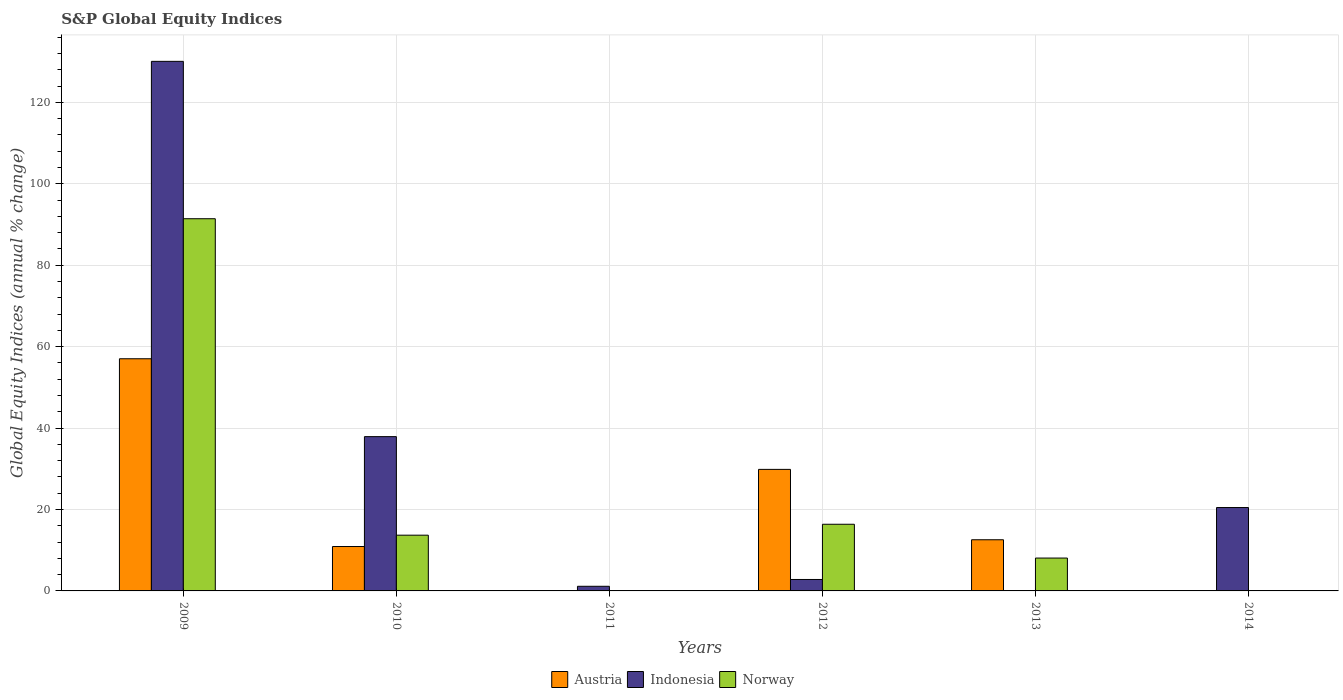Are the number of bars per tick equal to the number of legend labels?
Offer a terse response. No. Are the number of bars on each tick of the X-axis equal?
Keep it short and to the point. No. How many bars are there on the 5th tick from the left?
Provide a short and direct response. 2. In how many cases, is the number of bars for a given year not equal to the number of legend labels?
Ensure brevity in your answer.  3. What is the global equity indices in Norway in 2009?
Offer a terse response. 91.41. Across all years, what is the maximum global equity indices in Norway?
Give a very brief answer. 91.41. In which year was the global equity indices in Austria maximum?
Provide a succinct answer. 2009. What is the total global equity indices in Indonesia in the graph?
Your answer should be very brief. 192.39. What is the difference between the global equity indices in Indonesia in 2011 and that in 2014?
Offer a very short reply. -19.34. What is the difference between the global equity indices in Norway in 2009 and the global equity indices in Indonesia in 2013?
Keep it short and to the point. 91.41. What is the average global equity indices in Austria per year?
Make the answer very short. 18.39. In the year 2009, what is the difference between the global equity indices in Austria and global equity indices in Norway?
Give a very brief answer. -34.39. What is the ratio of the global equity indices in Indonesia in 2011 to that in 2014?
Provide a short and direct response. 0.06. What is the difference between the highest and the second highest global equity indices in Austria?
Keep it short and to the point. 27.17. What is the difference between the highest and the lowest global equity indices in Norway?
Offer a terse response. 91.41. Is the sum of the global equity indices in Indonesia in 2010 and 2014 greater than the maximum global equity indices in Austria across all years?
Make the answer very short. Yes. Is it the case that in every year, the sum of the global equity indices in Norway and global equity indices in Indonesia is greater than the global equity indices in Austria?
Your answer should be compact. No. How many years are there in the graph?
Your answer should be very brief. 6. What is the difference between two consecutive major ticks on the Y-axis?
Offer a terse response. 20. Does the graph contain grids?
Offer a terse response. Yes. How many legend labels are there?
Your response must be concise. 3. How are the legend labels stacked?
Give a very brief answer. Horizontal. What is the title of the graph?
Your answer should be compact. S&P Global Equity Indices. Does "Panama" appear as one of the legend labels in the graph?
Offer a terse response. No. What is the label or title of the Y-axis?
Offer a terse response. Global Equity Indices (annual % change). What is the Global Equity Indices (annual % change) of Austria in 2009?
Your response must be concise. 57.02. What is the Global Equity Indices (annual % change) of Indonesia in 2009?
Offer a terse response. 130.07. What is the Global Equity Indices (annual % change) in Norway in 2009?
Make the answer very short. 91.41. What is the Global Equity Indices (annual % change) of Austria in 2010?
Offer a terse response. 10.9. What is the Global Equity Indices (annual % change) of Indonesia in 2010?
Ensure brevity in your answer.  37.89. What is the Global Equity Indices (annual % change) in Norway in 2010?
Provide a succinct answer. 13.69. What is the Global Equity Indices (annual % change) of Indonesia in 2011?
Your answer should be compact. 1.14. What is the Global Equity Indices (annual % change) in Austria in 2012?
Your answer should be compact. 29.85. What is the Global Equity Indices (annual % change) in Indonesia in 2012?
Provide a short and direct response. 2.81. What is the Global Equity Indices (annual % change) of Norway in 2012?
Offer a very short reply. 16.37. What is the Global Equity Indices (annual % change) of Austria in 2013?
Offer a terse response. 12.57. What is the Global Equity Indices (annual % change) of Norway in 2013?
Offer a terse response. 8.07. What is the Global Equity Indices (annual % change) of Indonesia in 2014?
Provide a succinct answer. 20.48. What is the Global Equity Indices (annual % change) of Norway in 2014?
Your answer should be compact. 0. Across all years, what is the maximum Global Equity Indices (annual % change) of Austria?
Your answer should be very brief. 57.02. Across all years, what is the maximum Global Equity Indices (annual % change) of Indonesia?
Your answer should be compact. 130.07. Across all years, what is the maximum Global Equity Indices (annual % change) of Norway?
Provide a succinct answer. 91.41. Across all years, what is the minimum Global Equity Indices (annual % change) of Indonesia?
Your answer should be compact. 0. Across all years, what is the minimum Global Equity Indices (annual % change) of Norway?
Offer a terse response. 0. What is the total Global Equity Indices (annual % change) in Austria in the graph?
Offer a terse response. 110.35. What is the total Global Equity Indices (annual % change) in Indonesia in the graph?
Ensure brevity in your answer.  192.39. What is the total Global Equity Indices (annual % change) in Norway in the graph?
Provide a succinct answer. 129.55. What is the difference between the Global Equity Indices (annual % change) in Austria in 2009 and that in 2010?
Your answer should be compact. 46.12. What is the difference between the Global Equity Indices (annual % change) in Indonesia in 2009 and that in 2010?
Keep it short and to the point. 92.17. What is the difference between the Global Equity Indices (annual % change) of Norway in 2009 and that in 2010?
Provide a succinct answer. 77.72. What is the difference between the Global Equity Indices (annual % change) of Indonesia in 2009 and that in 2011?
Give a very brief answer. 128.93. What is the difference between the Global Equity Indices (annual % change) of Austria in 2009 and that in 2012?
Your answer should be compact. 27.17. What is the difference between the Global Equity Indices (annual % change) in Indonesia in 2009 and that in 2012?
Your answer should be compact. 127.26. What is the difference between the Global Equity Indices (annual % change) of Norway in 2009 and that in 2012?
Give a very brief answer. 75.04. What is the difference between the Global Equity Indices (annual % change) in Austria in 2009 and that in 2013?
Offer a very short reply. 44.45. What is the difference between the Global Equity Indices (annual % change) in Norway in 2009 and that in 2013?
Your answer should be compact. 83.34. What is the difference between the Global Equity Indices (annual % change) in Indonesia in 2009 and that in 2014?
Offer a terse response. 109.59. What is the difference between the Global Equity Indices (annual % change) of Indonesia in 2010 and that in 2011?
Offer a very short reply. 36.76. What is the difference between the Global Equity Indices (annual % change) of Austria in 2010 and that in 2012?
Provide a succinct answer. -18.95. What is the difference between the Global Equity Indices (annual % change) of Indonesia in 2010 and that in 2012?
Your answer should be very brief. 35.08. What is the difference between the Global Equity Indices (annual % change) of Norway in 2010 and that in 2012?
Offer a very short reply. -2.68. What is the difference between the Global Equity Indices (annual % change) in Austria in 2010 and that in 2013?
Make the answer very short. -1.66. What is the difference between the Global Equity Indices (annual % change) in Norway in 2010 and that in 2013?
Ensure brevity in your answer.  5.62. What is the difference between the Global Equity Indices (annual % change) in Indonesia in 2010 and that in 2014?
Your response must be concise. 17.41. What is the difference between the Global Equity Indices (annual % change) in Indonesia in 2011 and that in 2012?
Your response must be concise. -1.68. What is the difference between the Global Equity Indices (annual % change) in Indonesia in 2011 and that in 2014?
Your response must be concise. -19.34. What is the difference between the Global Equity Indices (annual % change) in Austria in 2012 and that in 2013?
Provide a succinct answer. 17.28. What is the difference between the Global Equity Indices (annual % change) in Indonesia in 2012 and that in 2014?
Offer a terse response. -17.67. What is the difference between the Global Equity Indices (annual % change) in Austria in 2009 and the Global Equity Indices (annual % change) in Indonesia in 2010?
Make the answer very short. 19.13. What is the difference between the Global Equity Indices (annual % change) in Austria in 2009 and the Global Equity Indices (annual % change) in Norway in 2010?
Provide a short and direct response. 43.33. What is the difference between the Global Equity Indices (annual % change) in Indonesia in 2009 and the Global Equity Indices (annual % change) in Norway in 2010?
Provide a succinct answer. 116.38. What is the difference between the Global Equity Indices (annual % change) in Austria in 2009 and the Global Equity Indices (annual % change) in Indonesia in 2011?
Your answer should be very brief. 55.89. What is the difference between the Global Equity Indices (annual % change) in Austria in 2009 and the Global Equity Indices (annual % change) in Indonesia in 2012?
Provide a short and direct response. 54.21. What is the difference between the Global Equity Indices (annual % change) of Austria in 2009 and the Global Equity Indices (annual % change) of Norway in 2012?
Offer a very short reply. 40.65. What is the difference between the Global Equity Indices (annual % change) in Indonesia in 2009 and the Global Equity Indices (annual % change) in Norway in 2012?
Provide a succinct answer. 113.7. What is the difference between the Global Equity Indices (annual % change) of Austria in 2009 and the Global Equity Indices (annual % change) of Norway in 2013?
Offer a very short reply. 48.95. What is the difference between the Global Equity Indices (annual % change) in Indonesia in 2009 and the Global Equity Indices (annual % change) in Norway in 2013?
Provide a succinct answer. 122. What is the difference between the Global Equity Indices (annual % change) in Austria in 2009 and the Global Equity Indices (annual % change) in Indonesia in 2014?
Provide a succinct answer. 36.54. What is the difference between the Global Equity Indices (annual % change) of Austria in 2010 and the Global Equity Indices (annual % change) of Indonesia in 2011?
Offer a terse response. 9.77. What is the difference between the Global Equity Indices (annual % change) in Austria in 2010 and the Global Equity Indices (annual % change) in Indonesia in 2012?
Ensure brevity in your answer.  8.09. What is the difference between the Global Equity Indices (annual % change) in Austria in 2010 and the Global Equity Indices (annual % change) in Norway in 2012?
Offer a very short reply. -5.47. What is the difference between the Global Equity Indices (annual % change) of Indonesia in 2010 and the Global Equity Indices (annual % change) of Norway in 2012?
Give a very brief answer. 21.52. What is the difference between the Global Equity Indices (annual % change) in Austria in 2010 and the Global Equity Indices (annual % change) in Norway in 2013?
Offer a very short reply. 2.83. What is the difference between the Global Equity Indices (annual % change) in Indonesia in 2010 and the Global Equity Indices (annual % change) in Norway in 2013?
Offer a terse response. 29.82. What is the difference between the Global Equity Indices (annual % change) in Austria in 2010 and the Global Equity Indices (annual % change) in Indonesia in 2014?
Offer a very short reply. -9.57. What is the difference between the Global Equity Indices (annual % change) in Indonesia in 2011 and the Global Equity Indices (annual % change) in Norway in 2012?
Provide a short and direct response. -15.24. What is the difference between the Global Equity Indices (annual % change) in Indonesia in 2011 and the Global Equity Indices (annual % change) in Norway in 2013?
Your response must be concise. -6.94. What is the difference between the Global Equity Indices (annual % change) of Austria in 2012 and the Global Equity Indices (annual % change) of Norway in 2013?
Provide a short and direct response. 21.78. What is the difference between the Global Equity Indices (annual % change) in Indonesia in 2012 and the Global Equity Indices (annual % change) in Norway in 2013?
Provide a succinct answer. -5.26. What is the difference between the Global Equity Indices (annual % change) of Austria in 2012 and the Global Equity Indices (annual % change) of Indonesia in 2014?
Your answer should be compact. 9.37. What is the difference between the Global Equity Indices (annual % change) of Austria in 2013 and the Global Equity Indices (annual % change) of Indonesia in 2014?
Offer a very short reply. -7.91. What is the average Global Equity Indices (annual % change) of Austria per year?
Offer a very short reply. 18.39. What is the average Global Equity Indices (annual % change) of Indonesia per year?
Provide a succinct answer. 32.06. What is the average Global Equity Indices (annual % change) of Norway per year?
Give a very brief answer. 21.59. In the year 2009, what is the difference between the Global Equity Indices (annual % change) in Austria and Global Equity Indices (annual % change) in Indonesia?
Keep it short and to the point. -73.05. In the year 2009, what is the difference between the Global Equity Indices (annual % change) of Austria and Global Equity Indices (annual % change) of Norway?
Provide a succinct answer. -34.39. In the year 2009, what is the difference between the Global Equity Indices (annual % change) in Indonesia and Global Equity Indices (annual % change) in Norway?
Keep it short and to the point. 38.65. In the year 2010, what is the difference between the Global Equity Indices (annual % change) in Austria and Global Equity Indices (annual % change) in Indonesia?
Offer a terse response. -26.99. In the year 2010, what is the difference between the Global Equity Indices (annual % change) of Austria and Global Equity Indices (annual % change) of Norway?
Provide a succinct answer. -2.78. In the year 2010, what is the difference between the Global Equity Indices (annual % change) of Indonesia and Global Equity Indices (annual % change) of Norway?
Your answer should be very brief. 24.2. In the year 2012, what is the difference between the Global Equity Indices (annual % change) of Austria and Global Equity Indices (annual % change) of Indonesia?
Keep it short and to the point. 27.04. In the year 2012, what is the difference between the Global Equity Indices (annual % change) of Austria and Global Equity Indices (annual % change) of Norway?
Your answer should be very brief. 13.48. In the year 2012, what is the difference between the Global Equity Indices (annual % change) in Indonesia and Global Equity Indices (annual % change) in Norway?
Offer a terse response. -13.56. In the year 2013, what is the difference between the Global Equity Indices (annual % change) of Austria and Global Equity Indices (annual % change) of Norway?
Offer a very short reply. 4.5. What is the ratio of the Global Equity Indices (annual % change) in Austria in 2009 to that in 2010?
Ensure brevity in your answer.  5.23. What is the ratio of the Global Equity Indices (annual % change) of Indonesia in 2009 to that in 2010?
Your response must be concise. 3.43. What is the ratio of the Global Equity Indices (annual % change) in Norway in 2009 to that in 2010?
Give a very brief answer. 6.68. What is the ratio of the Global Equity Indices (annual % change) of Indonesia in 2009 to that in 2011?
Ensure brevity in your answer.  114.51. What is the ratio of the Global Equity Indices (annual % change) of Austria in 2009 to that in 2012?
Provide a short and direct response. 1.91. What is the ratio of the Global Equity Indices (annual % change) in Indonesia in 2009 to that in 2012?
Offer a very short reply. 46.27. What is the ratio of the Global Equity Indices (annual % change) in Norway in 2009 to that in 2012?
Offer a very short reply. 5.58. What is the ratio of the Global Equity Indices (annual % change) of Austria in 2009 to that in 2013?
Offer a terse response. 4.54. What is the ratio of the Global Equity Indices (annual % change) in Norway in 2009 to that in 2013?
Ensure brevity in your answer.  11.33. What is the ratio of the Global Equity Indices (annual % change) of Indonesia in 2009 to that in 2014?
Your answer should be compact. 6.35. What is the ratio of the Global Equity Indices (annual % change) in Indonesia in 2010 to that in 2011?
Provide a short and direct response. 33.36. What is the ratio of the Global Equity Indices (annual % change) of Austria in 2010 to that in 2012?
Your response must be concise. 0.37. What is the ratio of the Global Equity Indices (annual % change) in Indonesia in 2010 to that in 2012?
Offer a terse response. 13.48. What is the ratio of the Global Equity Indices (annual % change) in Norway in 2010 to that in 2012?
Offer a very short reply. 0.84. What is the ratio of the Global Equity Indices (annual % change) of Austria in 2010 to that in 2013?
Your answer should be very brief. 0.87. What is the ratio of the Global Equity Indices (annual % change) in Norway in 2010 to that in 2013?
Offer a very short reply. 1.7. What is the ratio of the Global Equity Indices (annual % change) in Indonesia in 2010 to that in 2014?
Keep it short and to the point. 1.85. What is the ratio of the Global Equity Indices (annual % change) of Indonesia in 2011 to that in 2012?
Your answer should be very brief. 0.4. What is the ratio of the Global Equity Indices (annual % change) of Indonesia in 2011 to that in 2014?
Offer a terse response. 0.06. What is the ratio of the Global Equity Indices (annual % change) in Austria in 2012 to that in 2013?
Give a very brief answer. 2.38. What is the ratio of the Global Equity Indices (annual % change) of Norway in 2012 to that in 2013?
Give a very brief answer. 2.03. What is the ratio of the Global Equity Indices (annual % change) of Indonesia in 2012 to that in 2014?
Your response must be concise. 0.14. What is the difference between the highest and the second highest Global Equity Indices (annual % change) in Austria?
Provide a short and direct response. 27.17. What is the difference between the highest and the second highest Global Equity Indices (annual % change) in Indonesia?
Provide a succinct answer. 92.17. What is the difference between the highest and the second highest Global Equity Indices (annual % change) of Norway?
Make the answer very short. 75.04. What is the difference between the highest and the lowest Global Equity Indices (annual % change) in Austria?
Keep it short and to the point. 57.02. What is the difference between the highest and the lowest Global Equity Indices (annual % change) in Indonesia?
Give a very brief answer. 130.07. What is the difference between the highest and the lowest Global Equity Indices (annual % change) of Norway?
Your answer should be very brief. 91.41. 